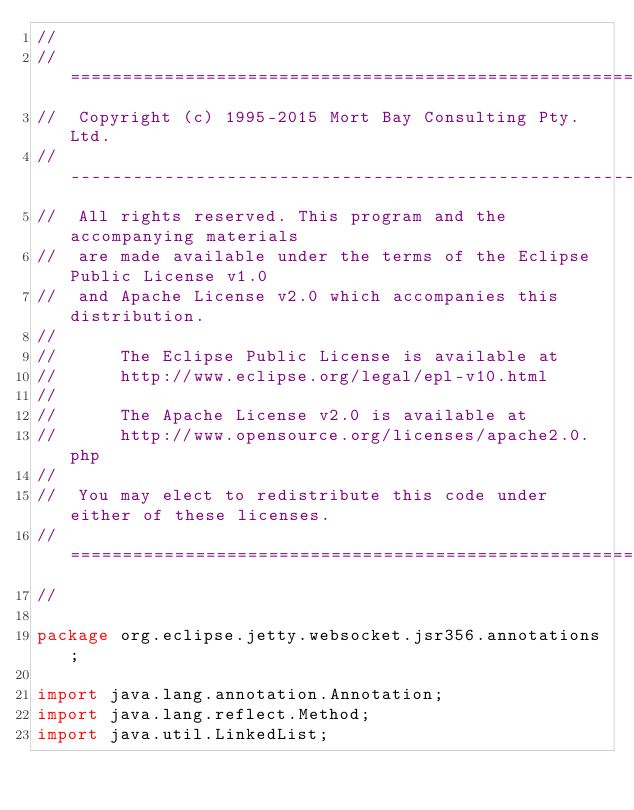Convert code to text. <code><loc_0><loc_0><loc_500><loc_500><_Java_>//
//  ========================================================================
//  Copyright (c) 1995-2015 Mort Bay Consulting Pty. Ltd.
//  ------------------------------------------------------------------------
//  All rights reserved. This program and the accompanying materials
//  are made available under the terms of the Eclipse Public License v1.0
//  and Apache License v2.0 which accompanies this distribution.
//
//      The Eclipse Public License is available at
//      http://www.eclipse.org/legal/epl-v10.html
//
//      The Apache License v2.0 is available at
//      http://www.opensource.org/licenses/apache2.0.php
//
//  You may elect to redistribute this code under either of these licenses.
//  ========================================================================
//

package org.eclipse.jetty.websocket.jsr356.annotations;

import java.lang.annotation.Annotation;
import java.lang.reflect.Method;
import java.util.LinkedList;</code> 